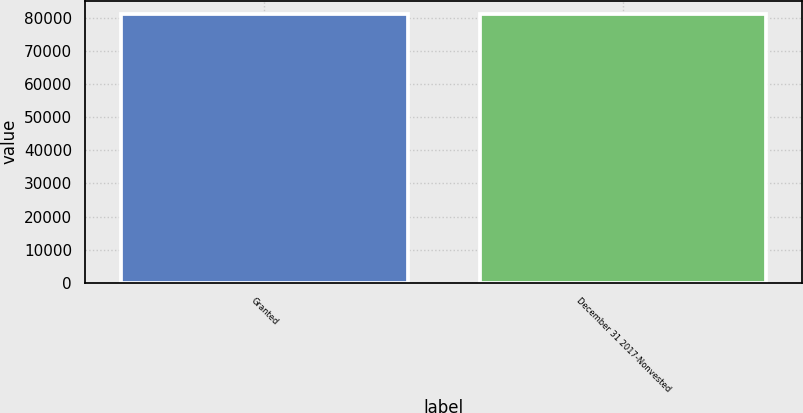Convert chart to OTSL. <chart><loc_0><loc_0><loc_500><loc_500><bar_chart><fcel>Granted<fcel>December 31 2017-Nonvested<nl><fcel>81068<fcel>81068.1<nl></chart> 